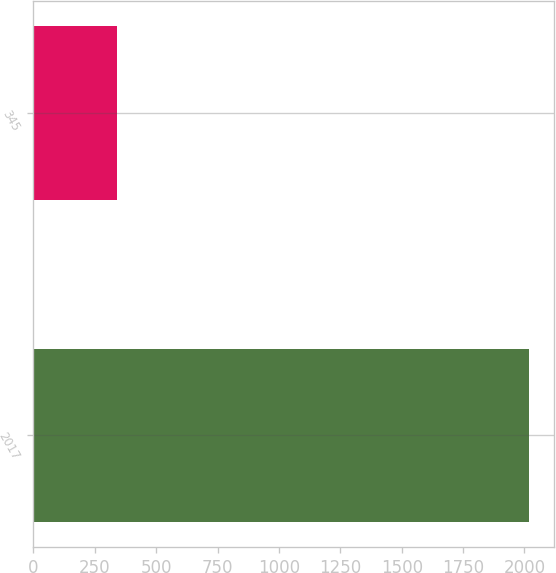Convert chart to OTSL. <chart><loc_0><loc_0><loc_500><loc_500><bar_chart><fcel>2017<fcel>345<nl><fcel>2018<fcel>342<nl></chart> 